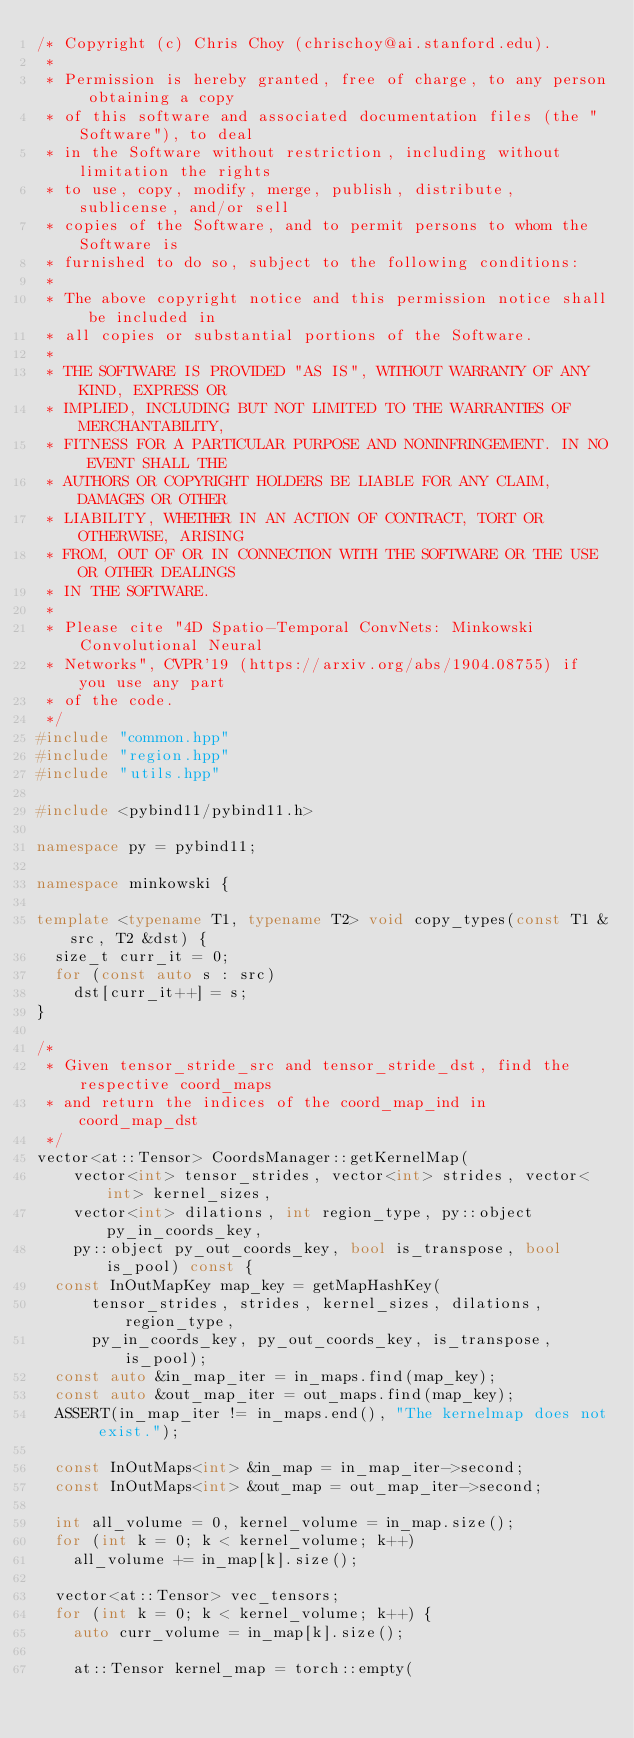Convert code to text. <code><loc_0><loc_0><loc_500><loc_500><_C++_>/* Copyright (c) Chris Choy (chrischoy@ai.stanford.edu).
 *
 * Permission is hereby granted, free of charge, to any person obtaining a copy
 * of this software and associated documentation files (the "Software"), to deal
 * in the Software without restriction, including without limitation the rights
 * to use, copy, modify, merge, publish, distribute, sublicense, and/or sell
 * copies of the Software, and to permit persons to whom the Software is
 * furnished to do so, subject to the following conditions:
 *
 * The above copyright notice and this permission notice shall be included in
 * all copies or substantial portions of the Software.
 *
 * THE SOFTWARE IS PROVIDED "AS IS", WITHOUT WARRANTY OF ANY KIND, EXPRESS OR
 * IMPLIED, INCLUDING BUT NOT LIMITED TO THE WARRANTIES OF MERCHANTABILITY,
 * FITNESS FOR A PARTICULAR PURPOSE AND NONINFRINGEMENT. IN NO EVENT SHALL THE
 * AUTHORS OR COPYRIGHT HOLDERS BE LIABLE FOR ANY CLAIM, DAMAGES OR OTHER
 * LIABILITY, WHETHER IN AN ACTION OF CONTRACT, TORT OR OTHERWISE, ARISING
 * FROM, OUT OF OR IN CONNECTION WITH THE SOFTWARE OR THE USE OR OTHER DEALINGS
 * IN THE SOFTWARE.
 *
 * Please cite "4D Spatio-Temporal ConvNets: Minkowski Convolutional Neural
 * Networks", CVPR'19 (https://arxiv.org/abs/1904.08755) if you use any part
 * of the code.
 */
#include "common.hpp"
#include "region.hpp"
#include "utils.hpp"

#include <pybind11/pybind11.h>

namespace py = pybind11;

namespace minkowski {

template <typename T1, typename T2> void copy_types(const T1 &src, T2 &dst) {
  size_t curr_it = 0;
  for (const auto s : src)
    dst[curr_it++] = s;
}

/*
 * Given tensor_stride_src and tensor_stride_dst, find the respective coord_maps
 * and return the indices of the coord_map_ind in coord_map_dst
 */
vector<at::Tensor> CoordsManager::getKernelMap(
    vector<int> tensor_strides, vector<int> strides, vector<int> kernel_sizes,
    vector<int> dilations, int region_type, py::object py_in_coords_key,
    py::object py_out_coords_key, bool is_transpose, bool is_pool) const {
  const InOutMapKey map_key = getMapHashKey(
      tensor_strides, strides, kernel_sizes, dilations, region_type,
      py_in_coords_key, py_out_coords_key, is_transpose, is_pool);
  const auto &in_map_iter = in_maps.find(map_key);
  const auto &out_map_iter = out_maps.find(map_key);
  ASSERT(in_map_iter != in_maps.end(), "The kernelmap does not exist.");

  const InOutMaps<int> &in_map = in_map_iter->second;
  const InOutMaps<int> &out_map = out_map_iter->second;

  int all_volume = 0, kernel_volume = in_map.size();
  for (int k = 0; k < kernel_volume; k++)
    all_volume += in_map[k].size();

  vector<at::Tensor> vec_tensors;
  for (int k = 0; k < kernel_volume; k++) {
    auto curr_volume = in_map[k].size();

    at::Tensor kernel_map = torch::empty(</code> 